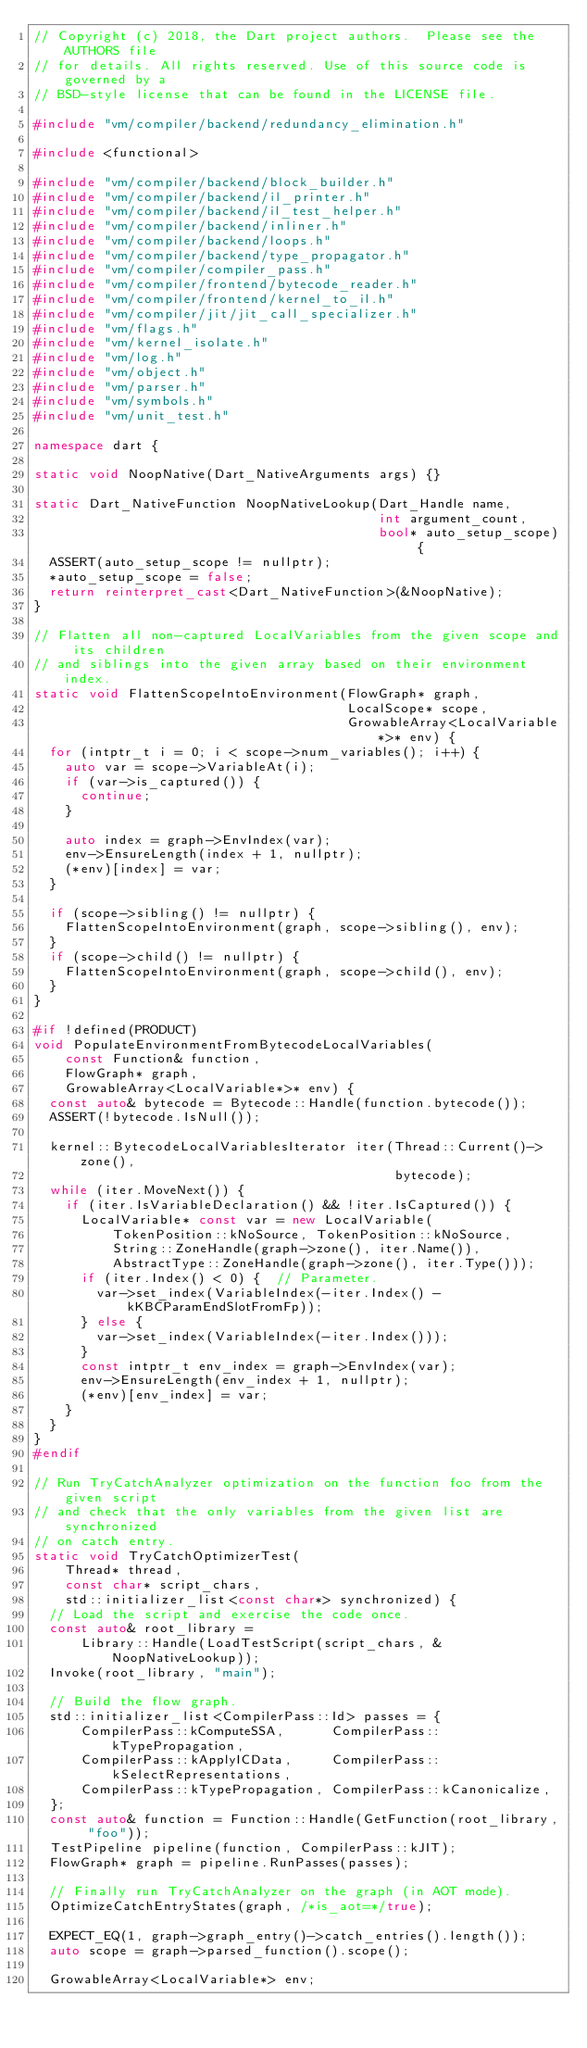<code> <loc_0><loc_0><loc_500><loc_500><_C++_>// Copyright (c) 2018, the Dart project authors.  Please see the AUTHORS file
// for details. All rights reserved. Use of this source code is governed by a
// BSD-style license that can be found in the LICENSE file.

#include "vm/compiler/backend/redundancy_elimination.h"

#include <functional>

#include "vm/compiler/backend/block_builder.h"
#include "vm/compiler/backend/il_printer.h"
#include "vm/compiler/backend/il_test_helper.h"
#include "vm/compiler/backend/inliner.h"
#include "vm/compiler/backend/loops.h"
#include "vm/compiler/backend/type_propagator.h"
#include "vm/compiler/compiler_pass.h"
#include "vm/compiler/frontend/bytecode_reader.h"
#include "vm/compiler/frontend/kernel_to_il.h"
#include "vm/compiler/jit/jit_call_specializer.h"
#include "vm/flags.h"
#include "vm/kernel_isolate.h"
#include "vm/log.h"
#include "vm/object.h"
#include "vm/parser.h"
#include "vm/symbols.h"
#include "vm/unit_test.h"

namespace dart {

static void NoopNative(Dart_NativeArguments args) {}

static Dart_NativeFunction NoopNativeLookup(Dart_Handle name,
                                            int argument_count,
                                            bool* auto_setup_scope) {
  ASSERT(auto_setup_scope != nullptr);
  *auto_setup_scope = false;
  return reinterpret_cast<Dart_NativeFunction>(&NoopNative);
}

// Flatten all non-captured LocalVariables from the given scope and its children
// and siblings into the given array based on their environment index.
static void FlattenScopeIntoEnvironment(FlowGraph* graph,
                                        LocalScope* scope,
                                        GrowableArray<LocalVariable*>* env) {
  for (intptr_t i = 0; i < scope->num_variables(); i++) {
    auto var = scope->VariableAt(i);
    if (var->is_captured()) {
      continue;
    }

    auto index = graph->EnvIndex(var);
    env->EnsureLength(index + 1, nullptr);
    (*env)[index] = var;
  }

  if (scope->sibling() != nullptr) {
    FlattenScopeIntoEnvironment(graph, scope->sibling(), env);
  }
  if (scope->child() != nullptr) {
    FlattenScopeIntoEnvironment(graph, scope->child(), env);
  }
}

#if !defined(PRODUCT)
void PopulateEnvironmentFromBytecodeLocalVariables(
    const Function& function,
    FlowGraph* graph,
    GrowableArray<LocalVariable*>* env) {
  const auto& bytecode = Bytecode::Handle(function.bytecode());
  ASSERT(!bytecode.IsNull());

  kernel::BytecodeLocalVariablesIterator iter(Thread::Current()->zone(),
                                              bytecode);
  while (iter.MoveNext()) {
    if (iter.IsVariableDeclaration() && !iter.IsCaptured()) {
      LocalVariable* const var = new LocalVariable(
          TokenPosition::kNoSource, TokenPosition::kNoSource,
          String::ZoneHandle(graph->zone(), iter.Name()),
          AbstractType::ZoneHandle(graph->zone(), iter.Type()));
      if (iter.Index() < 0) {  // Parameter.
        var->set_index(VariableIndex(-iter.Index() - kKBCParamEndSlotFromFp));
      } else {
        var->set_index(VariableIndex(-iter.Index()));
      }
      const intptr_t env_index = graph->EnvIndex(var);
      env->EnsureLength(env_index + 1, nullptr);
      (*env)[env_index] = var;
    }
  }
}
#endif

// Run TryCatchAnalyzer optimization on the function foo from the given script
// and check that the only variables from the given list are synchronized
// on catch entry.
static void TryCatchOptimizerTest(
    Thread* thread,
    const char* script_chars,
    std::initializer_list<const char*> synchronized) {
  // Load the script and exercise the code once.
  const auto& root_library =
      Library::Handle(LoadTestScript(script_chars, &NoopNativeLookup));
  Invoke(root_library, "main");

  // Build the flow graph.
  std::initializer_list<CompilerPass::Id> passes = {
      CompilerPass::kComputeSSA,      CompilerPass::kTypePropagation,
      CompilerPass::kApplyICData,     CompilerPass::kSelectRepresentations,
      CompilerPass::kTypePropagation, CompilerPass::kCanonicalize,
  };
  const auto& function = Function::Handle(GetFunction(root_library, "foo"));
  TestPipeline pipeline(function, CompilerPass::kJIT);
  FlowGraph* graph = pipeline.RunPasses(passes);

  // Finally run TryCatchAnalyzer on the graph (in AOT mode).
  OptimizeCatchEntryStates(graph, /*is_aot=*/true);

  EXPECT_EQ(1, graph->graph_entry()->catch_entries().length());
  auto scope = graph->parsed_function().scope();

  GrowableArray<LocalVariable*> env;</code> 